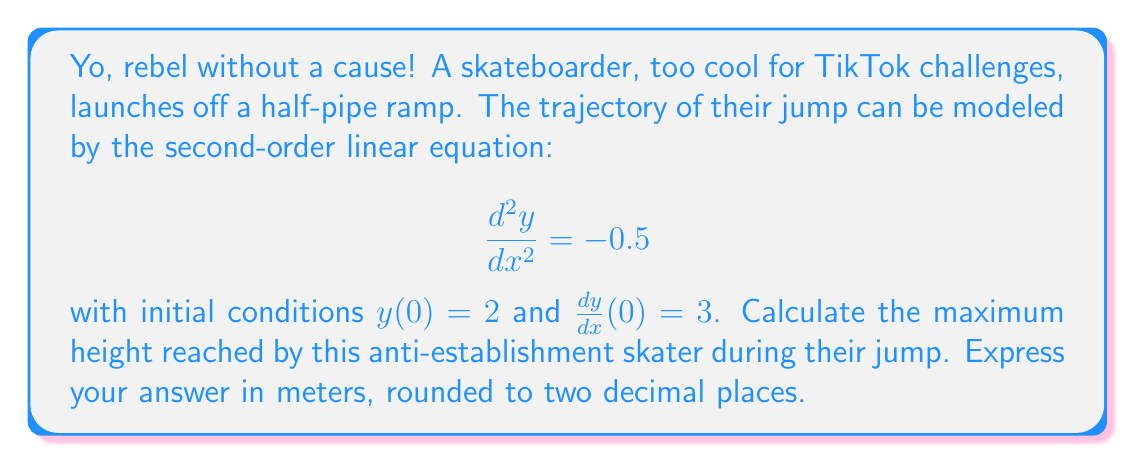Solve this math problem. Alright, let's break this down without any mainstream fluff:

1) We start with the given second-order linear equation:
   $$ \frac{d^2y}{dx^2} = -0.5 $$

2) To solve this, we need to integrate twice:
   Integrating once: $\frac{dy}{dx} = -0.5x + C_1$
   Integrating again: $y = -0.25x^2 + C_1x + C_2$

3) Now, we use the initial conditions to find $C_1$ and $C_2$:
   - $y(0) = 2$ implies $C_2 = 2$
   - $\frac{dy}{dx}(0) = 3$ implies $C_1 = 3$

4) Substituting these values:
   $$ y = -0.25x^2 + 3x + 2 $$

5) To find the maximum height, we need to find where $\frac{dy}{dx} = 0$:
   $$ \frac{dy}{dx} = -0.5x + 3 = 0 $$
   $$ x = 6 $$

6) Plugging this x-value back into our equation:
   $$ y_{max} = -0.25(6)^2 + 3(6) + 2 $$
   $$ y_{max} = -9 + 18 + 2 = 11 $$

Therefore, the maximum height reached is 11 meters.
Answer: 11.00 meters 